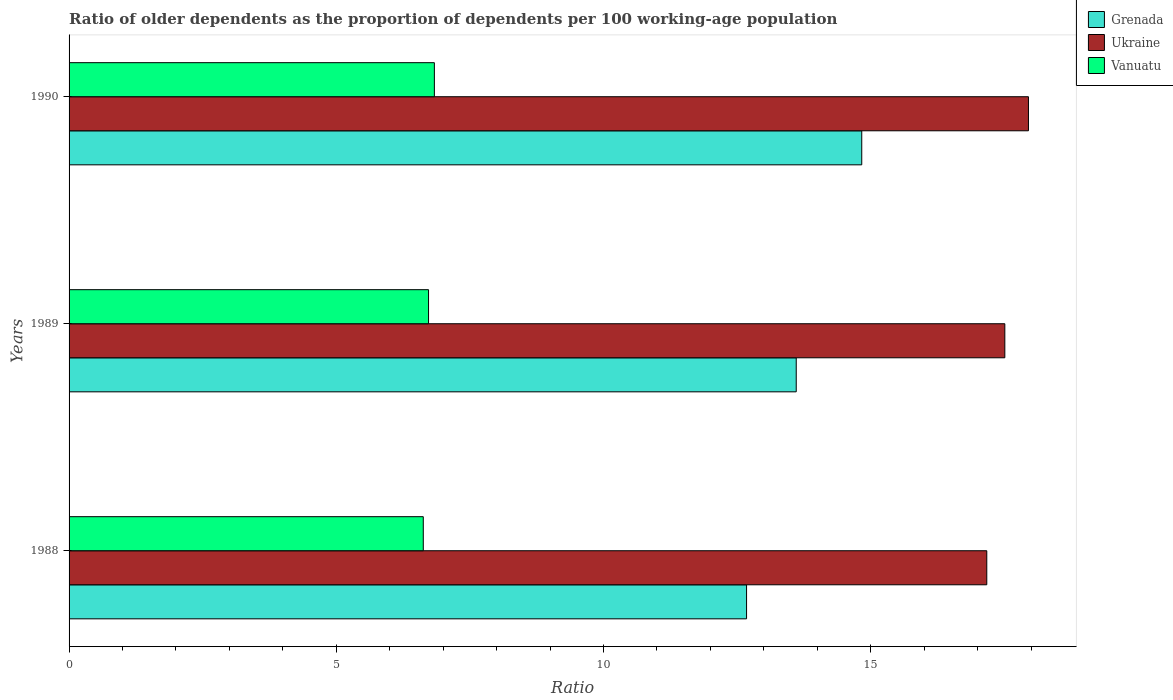How many groups of bars are there?
Offer a terse response. 3. Are the number of bars per tick equal to the number of legend labels?
Ensure brevity in your answer.  Yes. Are the number of bars on each tick of the Y-axis equal?
Offer a very short reply. Yes. How many bars are there on the 3rd tick from the top?
Provide a short and direct response. 3. How many bars are there on the 1st tick from the bottom?
Keep it short and to the point. 3. In how many cases, is the number of bars for a given year not equal to the number of legend labels?
Your answer should be compact. 0. What is the age dependency ratio(old) in Grenada in 1988?
Keep it short and to the point. 12.68. Across all years, what is the maximum age dependency ratio(old) in Grenada?
Offer a very short reply. 14.83. Across all years, what is the minimum age dependency ratio(old) in Vanuatu?
Offer a terse response. 6.63. In which year was the age dependency ratio(old) in Vanuatu maximum?
Make the answer very short. 1990. In which year was the age dependency ratio(old) in Ukraine minimum?
Make the answer very short. 1988. What is the total age dependency ratio(old) in Ukraine in the graph?
Offer a terse response. 52.63. What is the difference between the age dependency ratio(old) in Ukraine in 1988 and that in 1990?
Provide a succinct answer. -0.78. What is the difference between the age dependency ratio(old) in Ukraine in 1990 and the age dependency ratio(old) in Grenada in 1988?
Your response must be concise. 5.27. What is the average age dependency ratio(old) in Grenada per year?
Offer a terse response. 13.7. In the year 1989, what is the difference between the age dependency ratio(old) in Grenada and age dependency ratio(old) in Ukraine?
Your answer should be very brief. -3.9. What is the ratio of the age dependency ratio(old) in Vanuatu in 1988 to that in 1989?
Provide a succinct answer. 0.99. Is the age dependency ratio(old) in Grenada in 1989 less than that in 1990?
Your response must be concise. Yes. What is the difference between the highest and the second highest age dependency ratio(old) in Ukraine?
Provide a succinct answer. 0.44. What is the difference between the highest and the lowest age dependency ratio(old) in Grenada?
Your response must be concise. 2.16. In how many years, is the age dependency ratio(old) in Ukraine greater than the average age dependency ratio(old) in Ukraine taken over all years?
Your response must be concise. 1. Is the sum of the age dependency ratio(old) in Ukraine in 1988 and 1989 greater than the maximum age dependency ratio(old) in Grenada across all years?
Your answer should be very brief. Yes. What does the 3rd bar from the top in 1990 represents?
Offer a terse response. Grenada. What does the 3rd bar from the bottom in 1988 represents?
Ensure brevity in your answer.  Vanuatu. How many bars are there?
Your answer should be compact. 9. What is the difference between two consecutive major ticks on the X-axis?
Your answer should be very brief. 5. Where does the legend appear in the graph?
Ensure brevity in your answer.  Top right. How many legend labels are there?
Your answer should be compact. 3. What is the title of the graph?
Offer a terse response. Ratio of older dependents as the proportion of dependents per 100 working-age population. Does "Slovenia" appear as one of the legend labels in the graph?
Your answer should be compact. No. What is the label or title of the X-axis?
Ensure brevity in your answer.  Ratio. What is the label or title of the Y-axis?
Provide a succinct answer. Years. What is the Ratio of Grenada in 1988?
Give a very brief answer. 12.68. What is the Ratio in Ukraine in 1988?
Offer a terse response. 17.17. What is the Ratio of Vanuatu in 1988?
Provide a succinct answer. 6.63. What is the Ratio of Grenada in 1989?
Your answer should be compact. 13.61. What is the Ratio of Ukraine in 1989?
Provide a short and direct response. 17.51. What is the Ratio of Vanuatu in 1989?
Give a very brief answer. 6.73. What is the Ratio in Grenada in 1990?
Your response must be concise. 14.83. What is the Ratio of Ukraine in 1990?
Keep it short and to the point. 17.95. What is the Ratio of Vanuatu in 1990?
Make the answer very short. 6.84. Across all years, what is the maximum Ratio in Grenada?
Provide a succinct answer. 14.83. Across all years, what is the maximum Ratio of Ukraine?
Offer a very short reply. 17.95. Across all years, what is the maximum Ratio of Vanuatu?
Your response must be concise. 6.84. Across all years, what is the minimum Ratio in Grenada?
Give a very brief answer. 12.68. Across all years, what is the minimum Ratio in Ukraine?
Your answer should be very brief. 17.17. Across all years, what is the minimum Ratio of Vanuatu?
Your answer should be very brief. 6.63. What is the total Ratio in Grenada in the graph?
Keep it short and to the point. 41.11. What is the total Ratio of Ukraine in the graph?
Give a very brief answer. 52.63. What is the total Ratio in Vanuatu in the graph?
Offer a terse response. 20.19. What is the difference between the Ratio of Grenada in 1988 and that in 1989?
Your answer should be compact. -0.93. What is the difference between the Ratio of Ukraine in 1988 and that in 1989?
Ensure brevity in your answer.  -0.34. What is the difference between the Ratio in Vanuatu in 1988 and that in 1989?
Give a very brief answer. -0.1. What is the difference between the Ratio of Grenada in 1988 and that in 1990?
Offer a terse response. -2.16. What is the difference between the Ratio of Ukraine in 1988 and that in 1990?
Your response must be concise. -0.78. What is the difference between the Ratio in Vanuatu in 1988 and that in 1990?
Your answer should be very brief. -0.21. What is the difference between the Ratio of Grenada in 1989 and that in 1990?
Offer a terse response. -1.23. What is the difference between the Ratio in Ukraine in 1989 and that in 1990?
Make the answer very short. -0.44. What is the difference between the Ratio of Vanuatu in 1989 and that in 1990?
Give a very brief answer. -0.11. What is the difference between the Ratio of Grenada in 1988 and the Ratio of Ukraine in 1989?
Keep it short and to the point. -4.83. What is the difference between the Ratio in Grenada in 1988 and the Ratio in Vanuatu in 1989?
Keep it short and to the point. 5.95. What is the difference between the Ratio of Ukraine in 1988 and the Ratio of Vanuatu in 1989?
Offer a terse response. 10.45. What is the difference between the Ratio in Grenada in 1988 and the Ratio in Ukraine in 1990?
Provide a short and direct response. -5.27. What is the difference between the Ratio of Grenada in 1988 and the Ratio of Vanuatu in 1990?
Provide a short and direct response. 5.84. What is the difference between the Ratio in Ukraine in 1988 and the Ratio in Vanuatu in 1990?
Keep it short and to the point. 10.34. What is the difference between the Ratio of Grenada in 1989 and the Ratio of Ukraine in 1990?
Provide a short and direct response. -4.34. What is the difference between the Ratio of Grenada in 1989 and the Ratio of Vanuatu in 1990?
Your response must be concise. 6.77. What is the difference between the Ratio in Ukraine in 1989 and the Ratio in Vanuatu in 1990?
Ensure brevity in your answer.  10.67. What is the average Ratio in Grenada per year?
Your response must be concise. 13.7. What is the average Ratio in Ukraine per year?
Offer a very short reply. 17.54. What is the average Ratio in Vanuatu per year?
Provide a succinct answer. 6.73. In the year 1988, what is the difference between the Ratio of Grenada and Ratio of Ukraine?
Your answer should be very brief. -4.49. In the year 1988, what is the difference between the Ratio of Grenada and Ratio of Vanuatu?
Make the answer very short. 6.05. In the year 1988, what is the difference between the Ratio of Ukraine and Ratio of Vanuatu?
Your answer should be very brief. 10.54. In the year 1989, what is the difference between the Ratio of Grenada and Ratio of Ukraine?
Provide a short and direct response. -3.9. In the year 1989, what is the difference between the Ratio of Grenada and Ratio of Vanuatu?
Offer a terse response. 6.88. In the year 1989, what is the difference between the Ratio in Ukraine and Ratio in Vanuatu?
Your response must be concise. 10.78. In the year 1990, what is the difference between the Ratio in Grenada and Ratio in Ukraine?
Your response must be concise. -3.12. In the year 1990, what is the difference between the Ratio of Grenada and Ratio of Vanuatu?
Offer a terse response. 8. In the year 1990, what is the difference between the Ratio of Ukraine and Ratio of Vanuatu?
Offer a very short reply. 11.12. What is the ratio of the Ratio of Grenada in 1988 to that in 1989?
Ensure brevity in your answer.  0.93. What is the ratio of the Ratio of Ukraine in 1988 to that in 1989?
Ensure brevity in your answer.  0.98. What is the ratio of the Ratio in Vanuatu in 1988 to that in 1989?
Your answer should be very brief. 0.99. What is the ratio of the Ratio of Grenada in 1988 to that in 1990?
Offer a very short reply. 0.85. What is the ratio of the Ratio in Ukraine in 1988 to that in 1990?
Offer a very short reply. 0.96. What is the ratio of the Ratio of Vanuatu in 1988 to that in 1990?
Ensure brevity in your answer.  0.97. What is the ratio of the Ratio of Grenada in 1989 to that in 1990?
Keep it short and to the point. 0.92. What is the ratio of the Ratio in Ukraine in 1989 to that in 1990?
Provide a succinct answer. 0.98. What is the ratio of the Ratio in Vanuatu in 1989 to that in 1990?
Offer a very short reply. 0.98. What is the difference between the highest and the second highest Ratio in Grenada?
Offer a terse response. 1.23. What is the difference between the highest and the second highest Ratio in Ukraine?
Offer a very short reply. 0.44. What is the difference between the highest and the second highest Ratio of Vanuatu?
Make the answer very short. 0.11. What is the difference between the highest and the lowest Ratio of Grenada?
Ensure brevity in your answer.  2.16. What is the difference between the highest and the lowest Ratio of Ukraine?
Ensure brevity in your answer.  0.78. What is the difference between the highest and the lowest Ratio in Vanuatu?
Offer a very short reply. 0.21. 